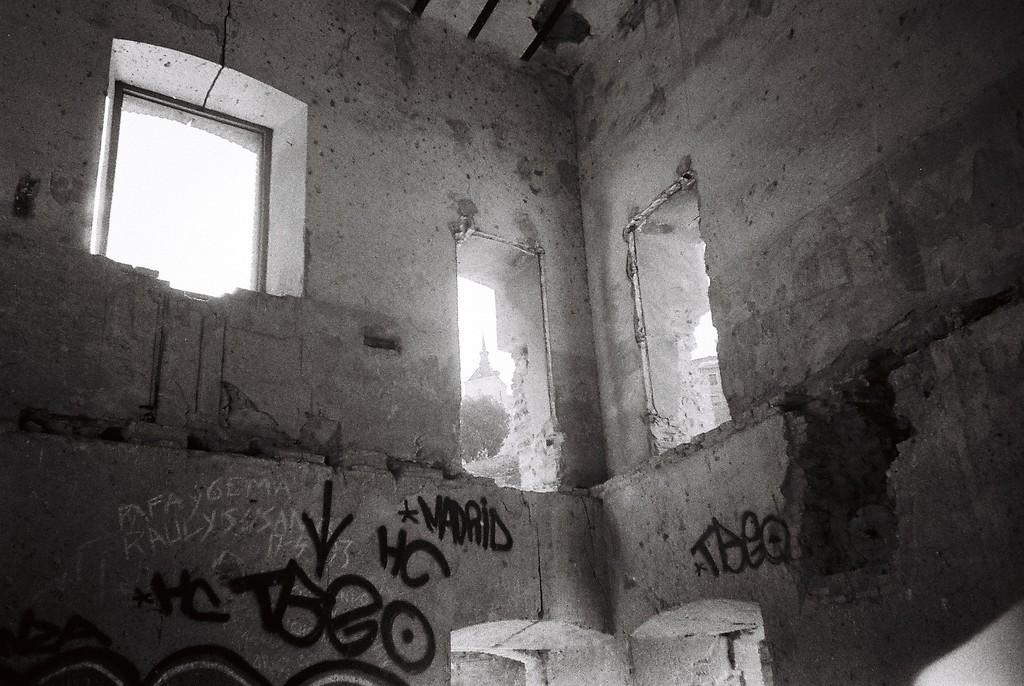What is the setting of the image? The image shows the inside of a building. What can be seen through the windows in the image? The windows in the image allow us to see outside the building. What is written or displayed on the wall in the image? There is text on the wall in the image. What type of amusement can be seen in the image? There is no amusement present in the image; it shows the inside of a building with windows and text on the wall. How does the expansion of the building affect the grandfather in the image? There is no grandfather or expansion of the building mentioned in the image. 